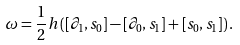Convert formula to latex. <formula><loc_0><loc_0><loc_500><loc_500>\omega = { \frac { 1 } { 2 } } h \left ( [ \partial _ { 1 } , s _ { 0 } ] - [ \partial _ { 0 } , s _ { 1 } ] + [ s _ { 0 } , s _ { 1 } ] \right ) .</formula> 